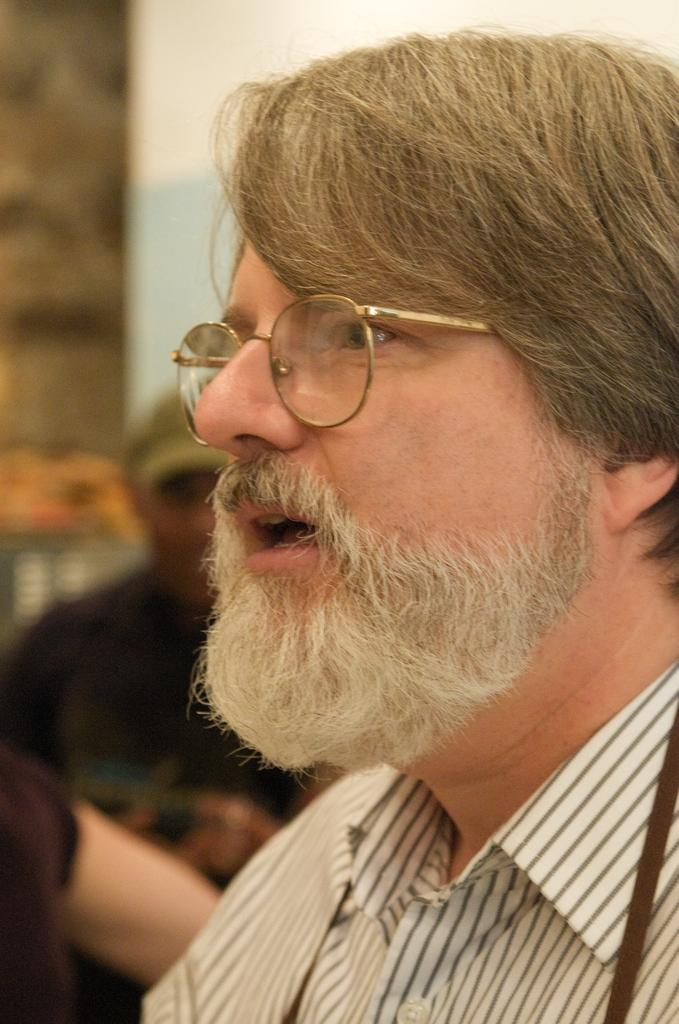Who is the main subject in the picture? There is a man in the picture. What can be observed about the man's facial features? The man has a beard and is wearing spectacles. What might the man be doing in the image? The man appears to be speaking. How is the background of the man depicted in the image? The background of the man is blurred. What type of orange is the man holding in the image? There is no orange present in the image; the man is not holding any fruit. What decision is the man's uncle making in the image? There is no mention of an uncle in the image, and therefore no decision can be attributed to him. 